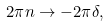<formula> <loc_0><loc_0><loc_500><loc_500>2 \pi n \to - 2 \pi \delta ,</formula> 